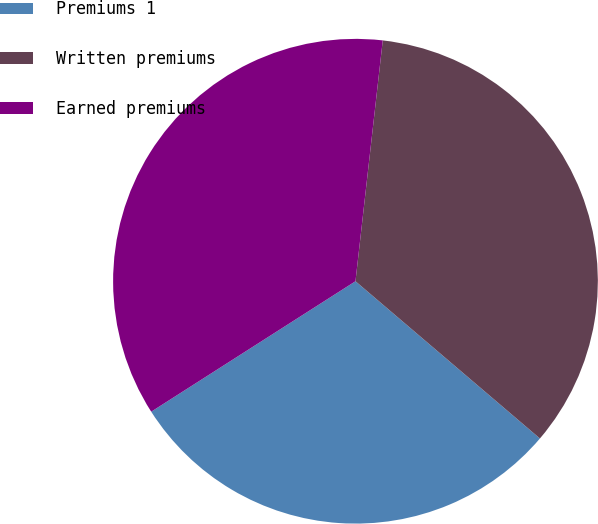<chart> <loc_0><loc_0><loc_500><loc_500><pie_chart><fcel>Premiums 1<fcel>Written premiums<fcel>Earned premiums<nl><fcel>29.72%<fcel>34.44%<fcel>35.84%<nl></chart> 